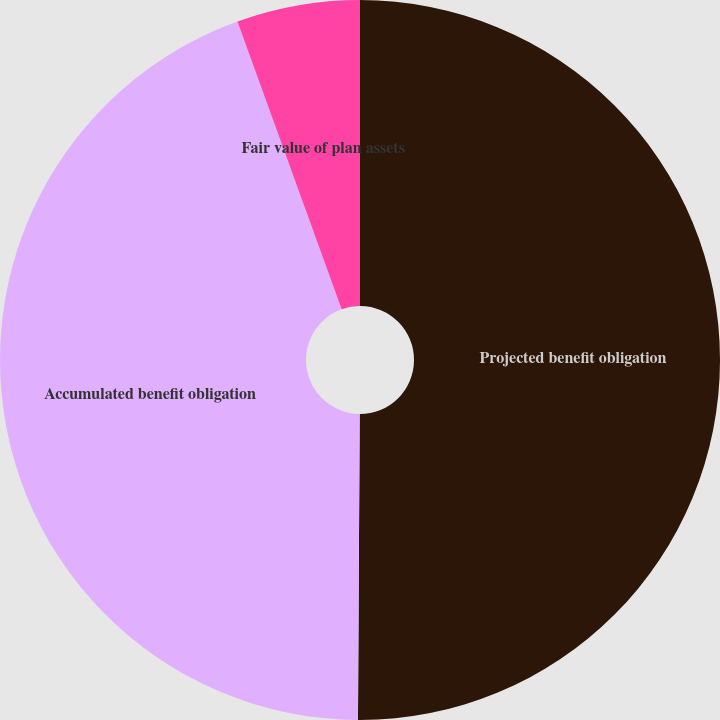Convert chart to OTSL. <chart><loc_0><loc_0><loc_500><loc_500><pie_chart><fcel>Projected benefit obligation<fcel>Accumulated benefit obligation<fcel>Fair value of plan assets<nl><fcel>50.09%<fcel>44.38%<fcel>5.53%<nl></chart> 